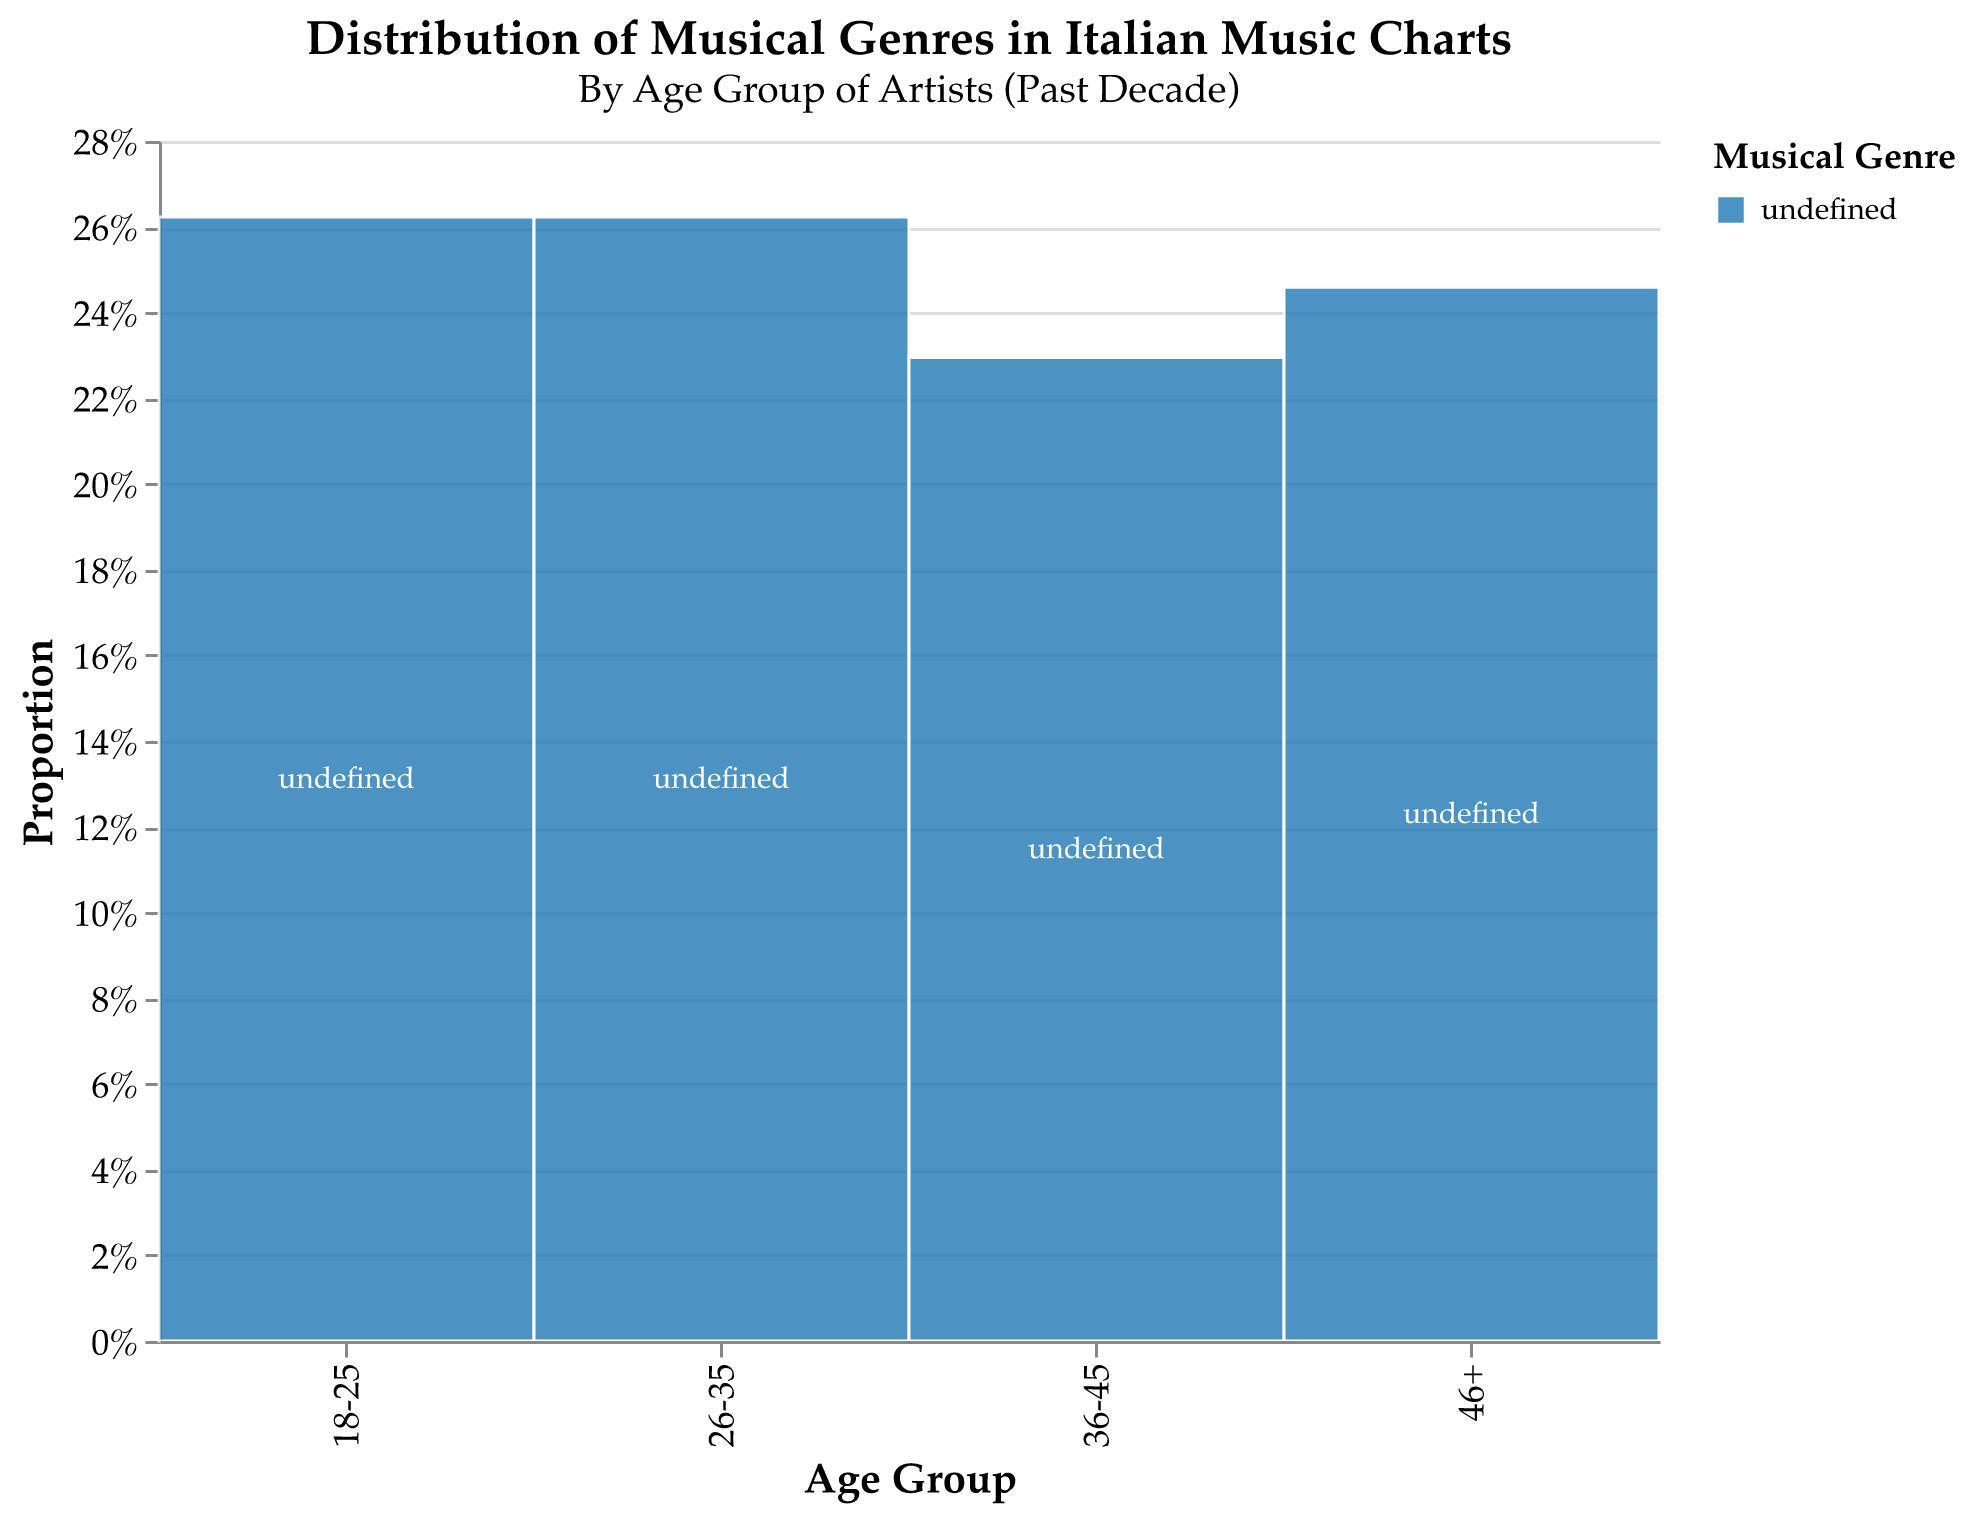What is the title of the plot? The title is at the top of the plot and it reads "Distribution of Musical Genres in Italian Music Charts", with the subtitle "By Age Group of Artists (Past Decade)".
Answer: Distribution of Musical Genres in Italian Music Charts Which genre is most popular among artists aged 18-25? The section of the plot for artists aged 18-25 shows the proportions of different genres. The largest proportion is light blue, representing the "Pop" genre.
Answer: Pop How does the popularity of "Cantautorato" change across different age groups? The plot shows that "Cantautorato" is present in three age groups: 26-35, 36-45, and 46+. In these groups, "Cantautorato" comprises 15%, 20%, and 30%, respectively.
Answer: Increases with age Which age group has the highest proportion of "Pop" artists? By comparing the sections labeled "Pop" across the different age groups, the 26-35 age group has the largest proportion at 35%.
Answer: 26-35 What percentage of artists aged 36-45 are in the "Jazz" genre? Locate the "36-45" age group section and look for the corresponding part for "Jazz". The figure shows 10%.
Answer: 10% Compare the popularity of "Indie" music between the age groups 18-25 and 26-35. In the mosaic plot, "Indie" is 15% for 18-25 and 10% for 26-35, indicating it is more popular among the younger group.
Answer: More popular in 18-25 Which genre is exclusive to the age group 46+? The plot shows genres only present in one age group. "Classical", "Folk", and "Opera" are present only in the 46+ group.
Answer: Classical, Folk, Opera What is the combined proportion of "Pop" and "Rock" in the 26-35 age group? Adding the proportions of "Pop" (35%) and "Rock" (20%) in the 26-35 age group results in 35% + 20% = 55%.
Answer: 55% How does the diversity of genres change from younger to older age groups? Younger groups (18-25, 26-35) have a higher number of different genres present, while older groups (46+) focus on fewer genres, primarily traditional or classical types.
Answer: Decreases with age What's the least represented genre for artists aged 18-25? The smallest section for the 18-25 age group in the plot is "Electronic", showing 10%.
Answer: Electronic 